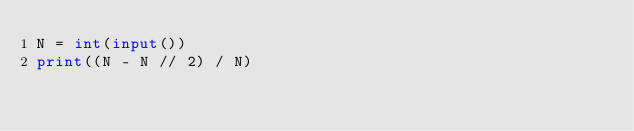Convert code to text. <code><loc_0><loc_0><loc_500><loc_500><_Python_>N = int(input())
print((N - N // 2) / N)</code> 